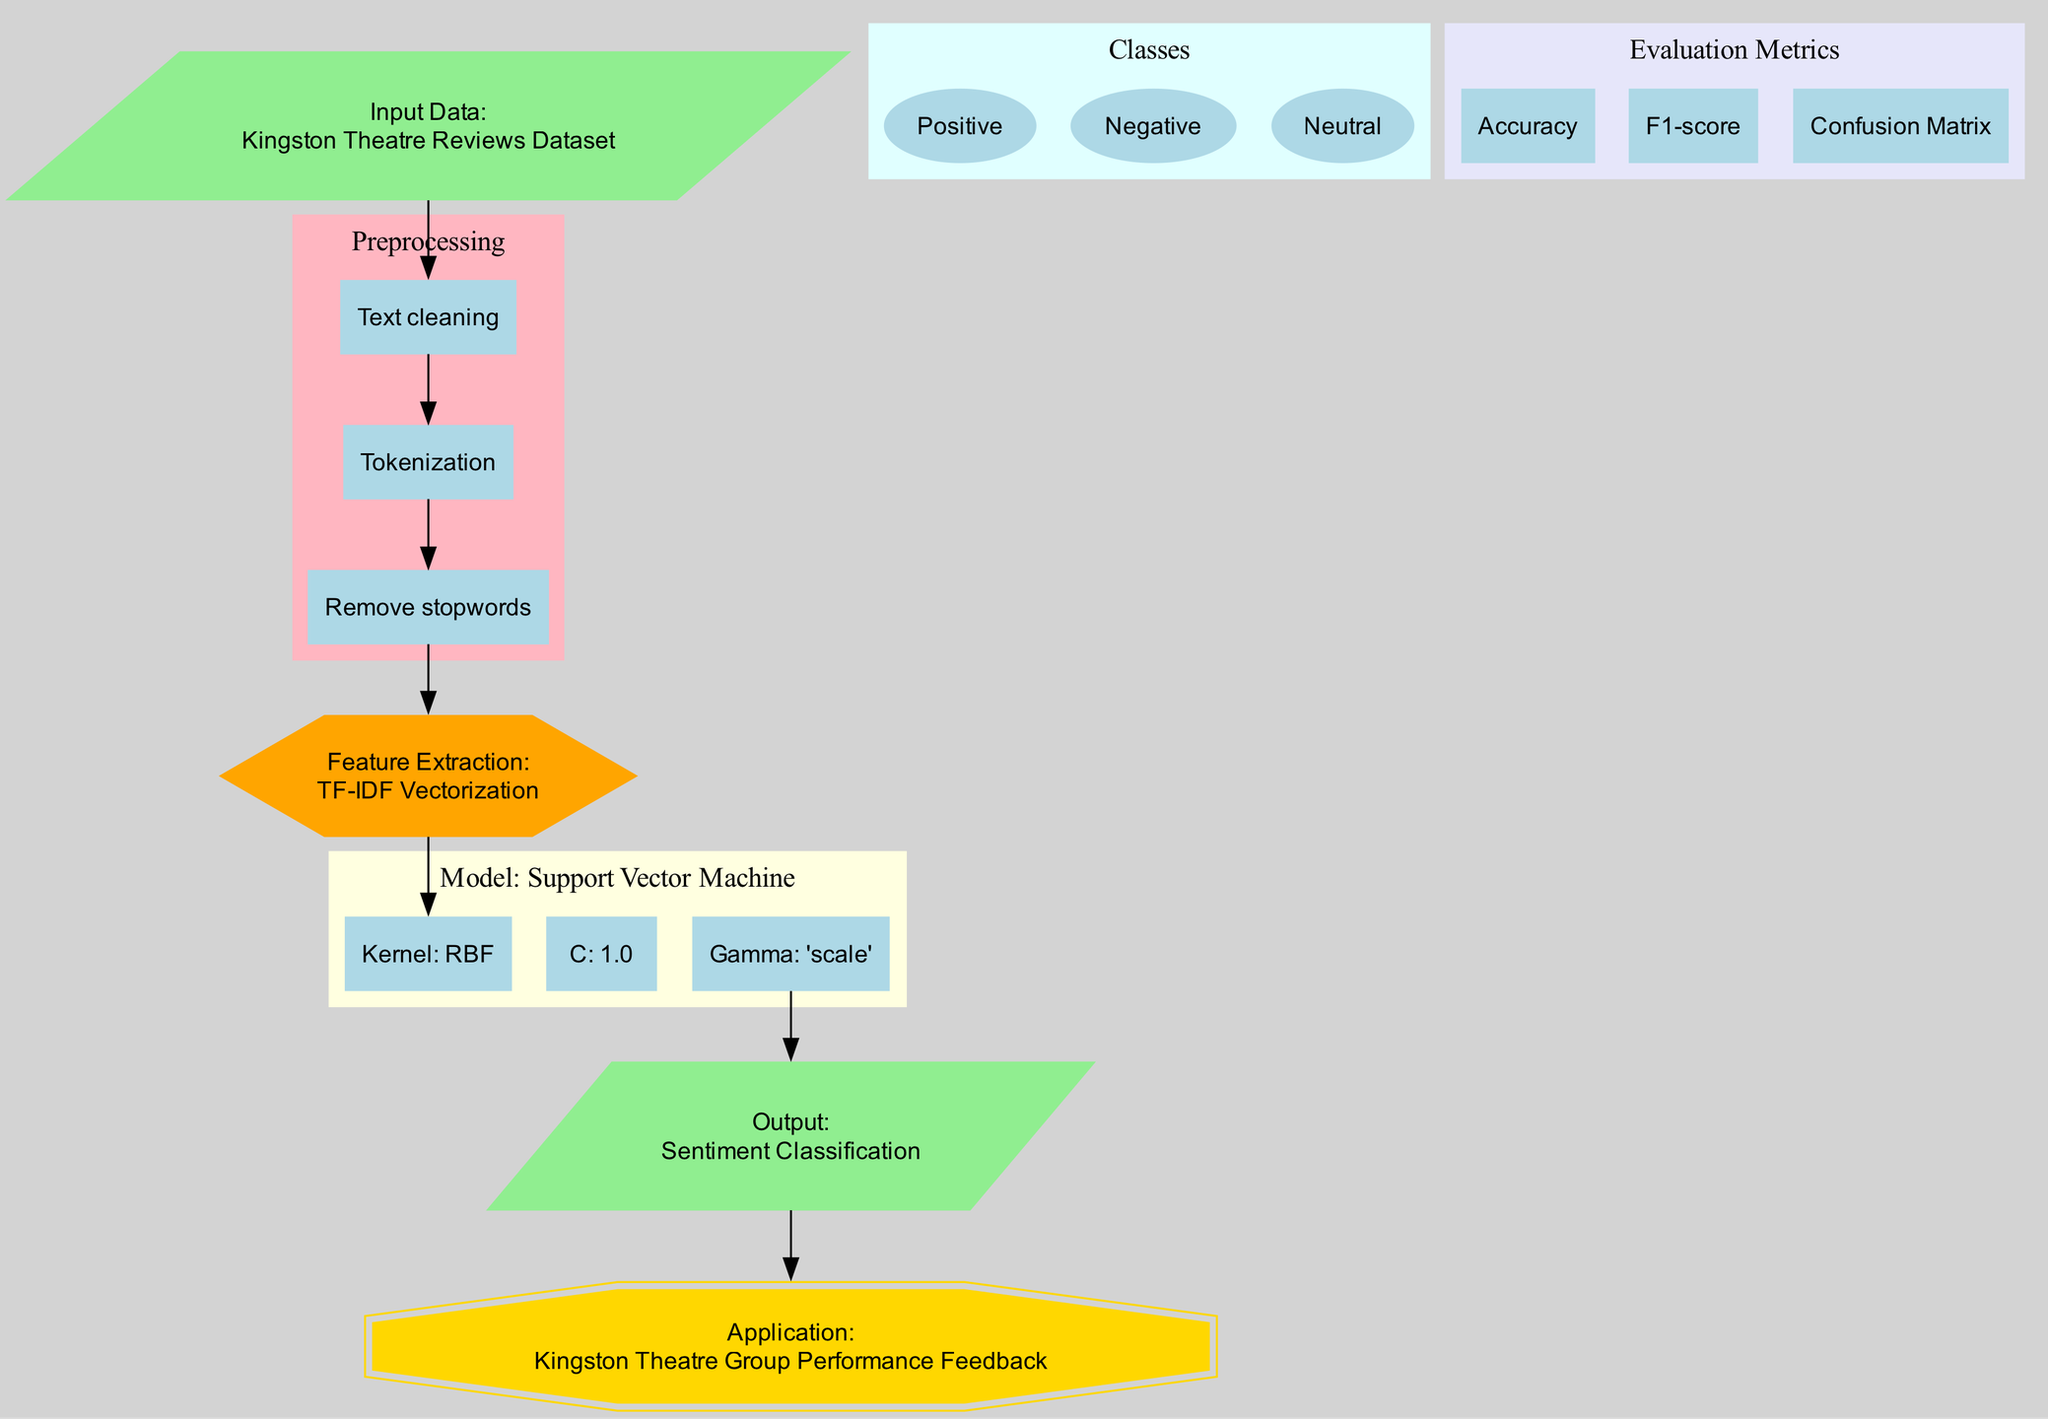What is the input data for the model? The diagram specifies the input data as "Kingston Theatre Reviews Dataset," which is the starting point for the entire process.
Answer: Kingston Theatre Reviews Dataset What is the first step in preprocessing? The preprocessing steps are listed in order, and the first step is "Text cleaning," which initiates the data preparation process.
Answer: Text cleaning How many hyperparameters are used in the model? The hyperparameters section lists three specific parameters: Kernel, C, and Gamma, indicating that there are three in total.
Answer: 3 What type of model is being used for classification? The diagram identifies the model as a "Support Vector Machine," which is clearly stated in the model section.
Answer: Support Vector Machine What are the output classes of the model? The classes section lists three specific sentiments: Positive, Negative, and Neutral, which are the possible outputs of the classification.
Answer: Positive, Negative, Neutral How do the evaluation metrics relate to the model output? The evaluation metrics are positioned to follow the model's hyperparameters in the flow, indicating that they assess the output performance of the model, specifically looking at overall effectiveness.
Answer: They assess model performance What is the purpose of applying this model? The application is detailed in a distinct node stating it is for "Kingston Theatre Group Performance Feedback," which indicates the goal of using this model.
Answer: Kingston Theatre Group Performance Feedback Which preprocessing step comes before feature extraction? The final step in the preprocessing sequence is "Remove stopwords," which directly leads into the feature extraction process according to the diagram flow.
Answer: Remove stopwords What is the shape of the node that represents the output? The diagram describes the output node as having a "parallelogram" shape, which is a specific design choice made for clarity.
Answer: Parallelogram 